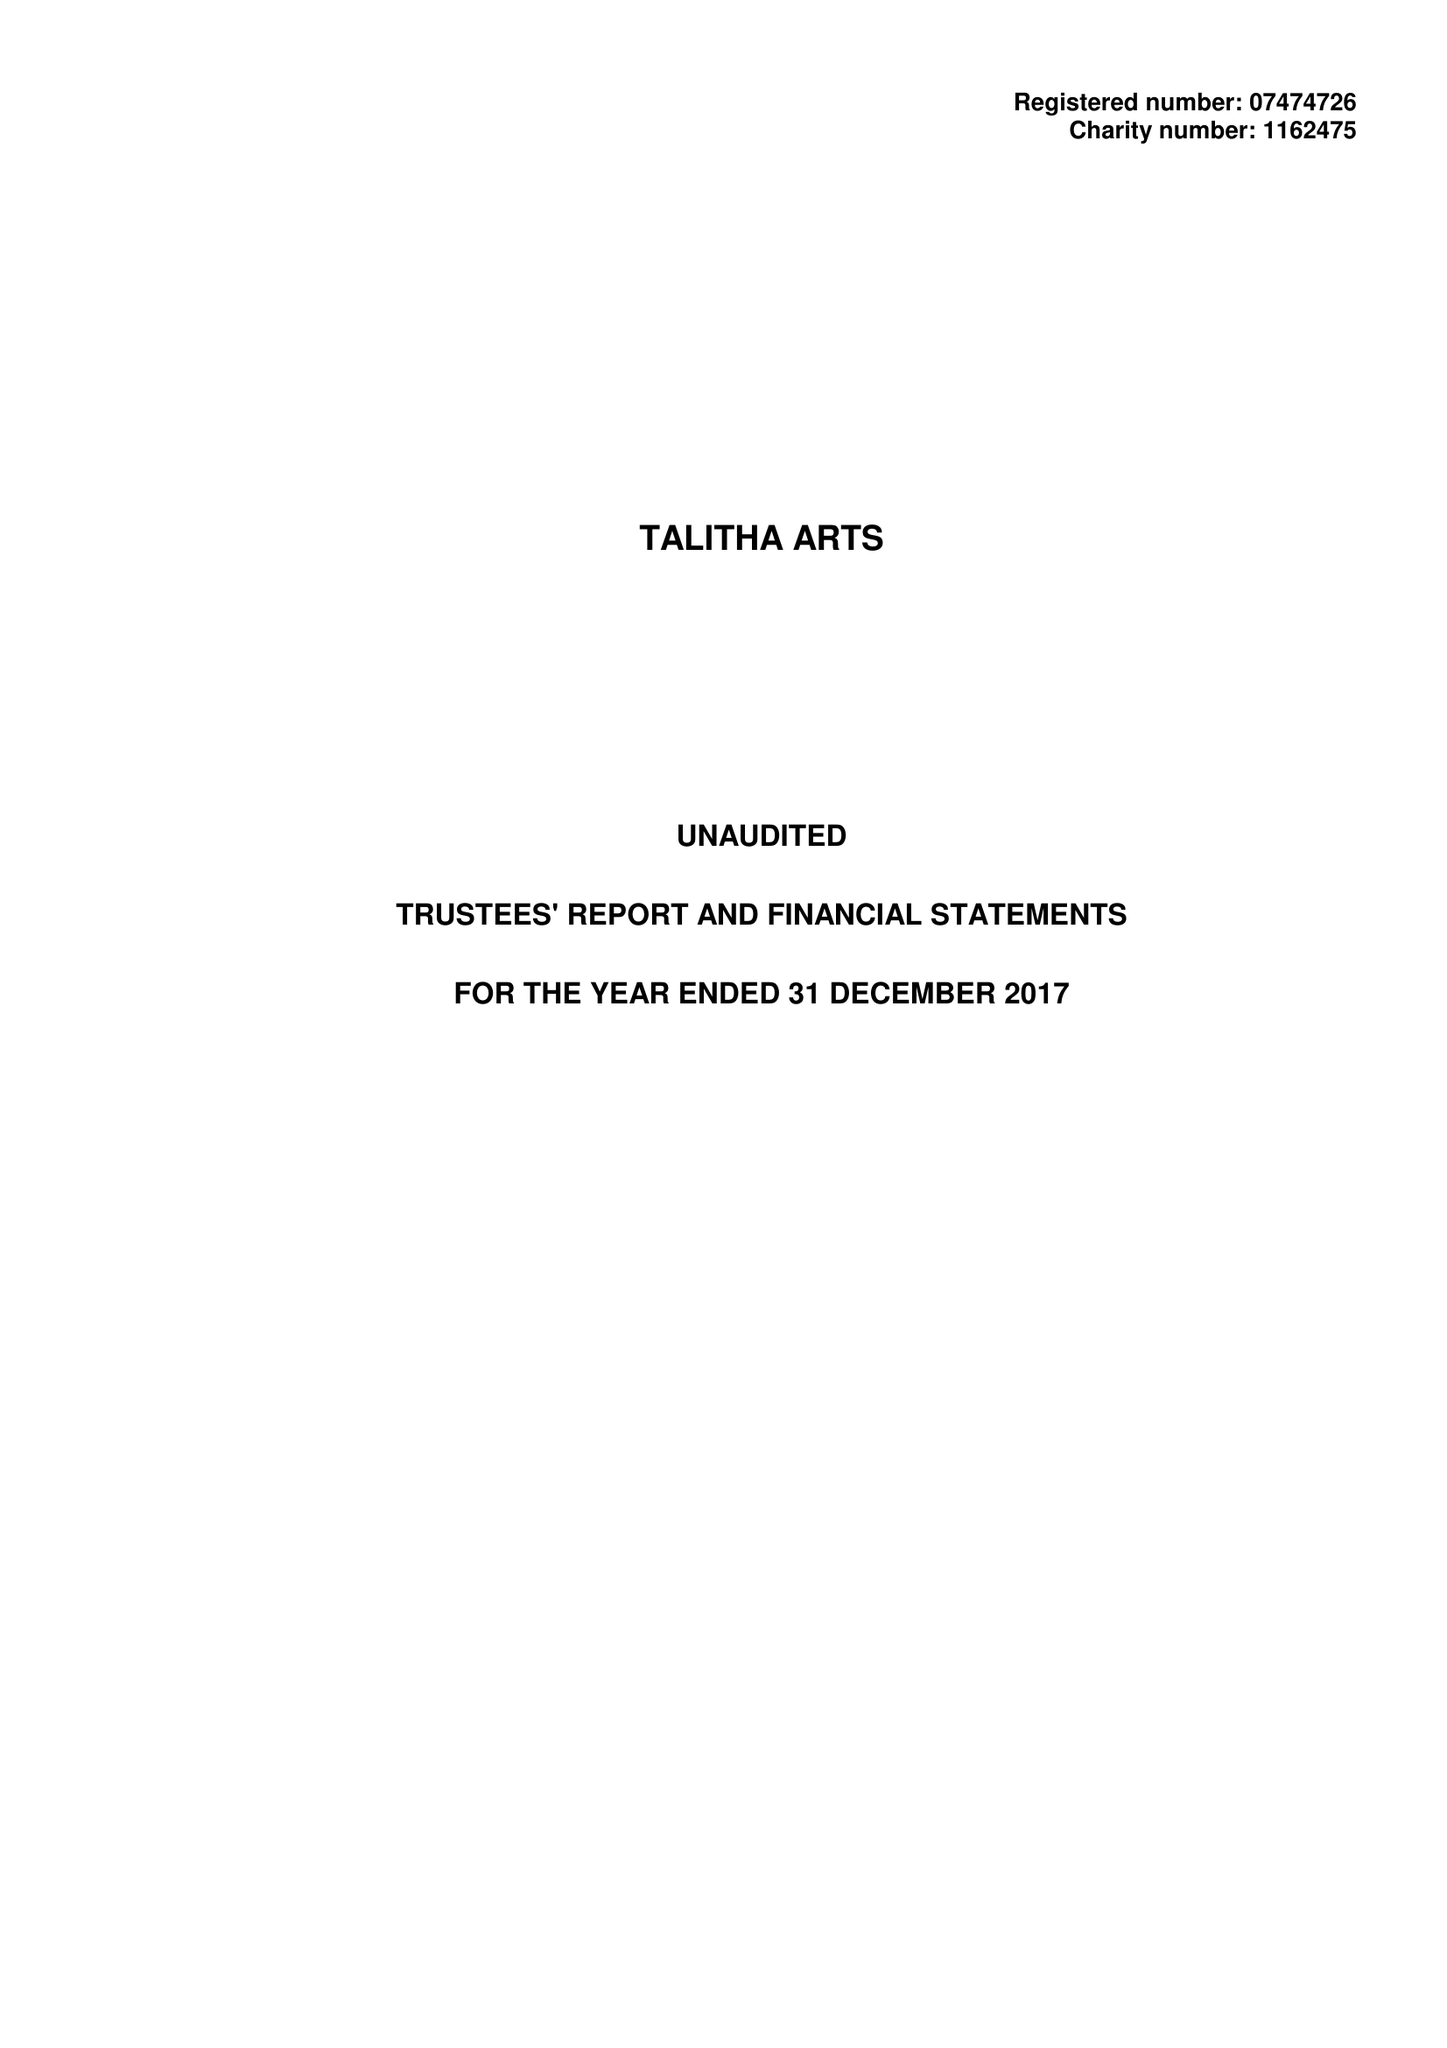What is the value for the report_date?
Answer the question using a single word or phrase. 2017-12-31 